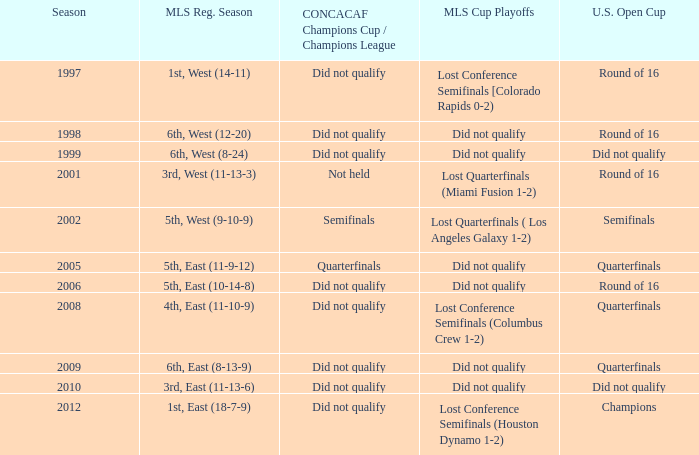How did the team place when they did not qualify for the Concaf Champions Cup but made it to Round of 16 in the U.S. Open Cup? Lost Conference Semifinals [Colorado Rapids 0-2), Did not qualify, Did not qualify. 